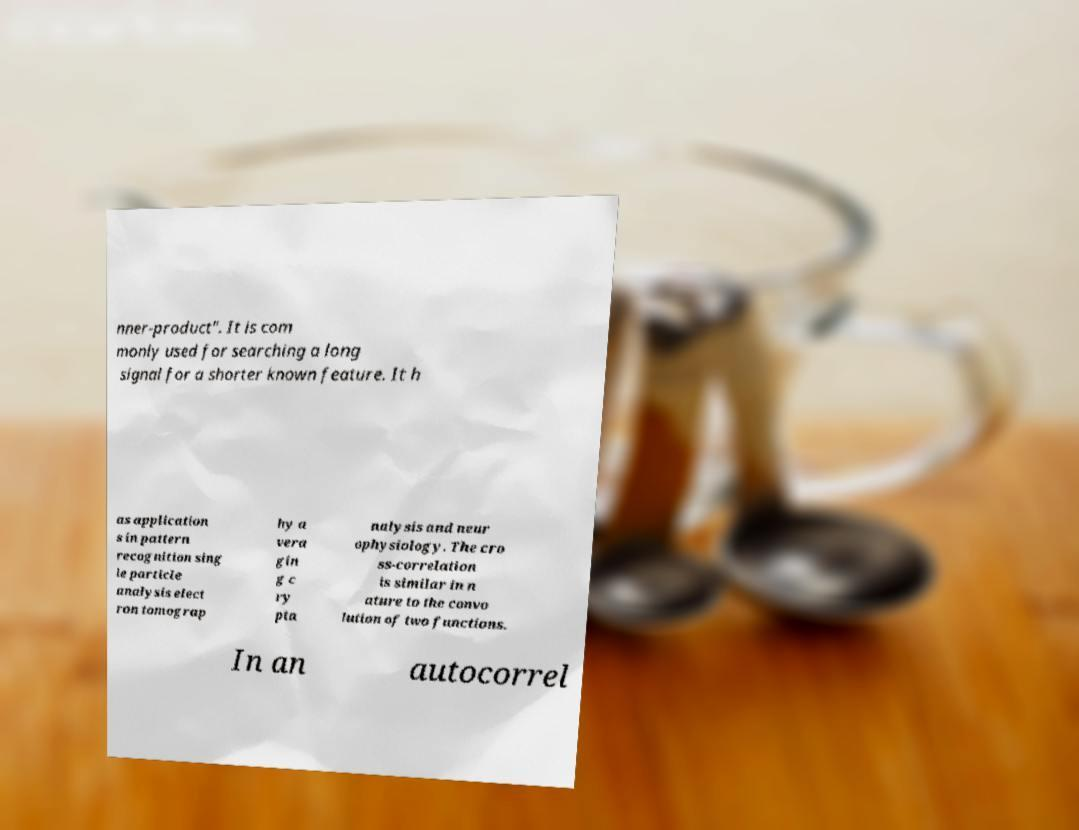For documentation purposes, I need the text within this image transcribed. Could you provide that? nner-product". It is com monly used for searching a long signal for a shorter known feature. It h as application s in pattern recognition sing le particle analysis elect ron tomograp hy a vera gin g c ry pta nalysis and neur ophysiology. The cro ss-correlation is similar in n ature to the convo lution of two functions. In an autocorrel 